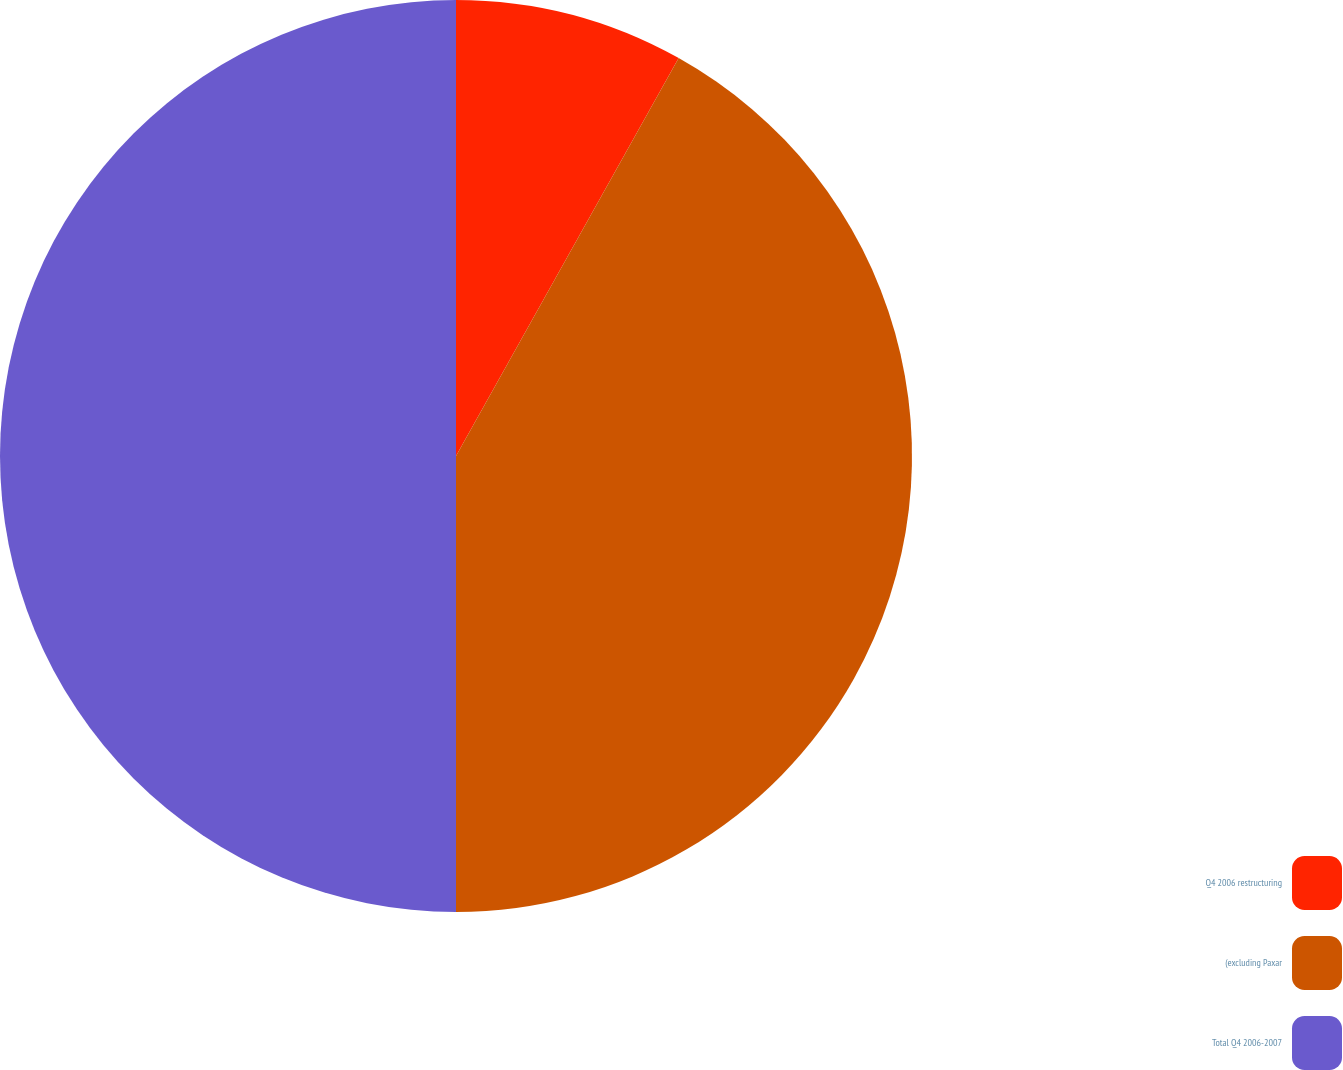<chart> <loc_0><loc_0><loc_500><loc_500><pie_chart><fcel>Q4 2006 restructuring<fcel>(excluding Paxar<fcel>Total Q4 2006-2007<nl><fcel>8.12%<fcel>41.88%<fcel>50.0%<nl></chart> 